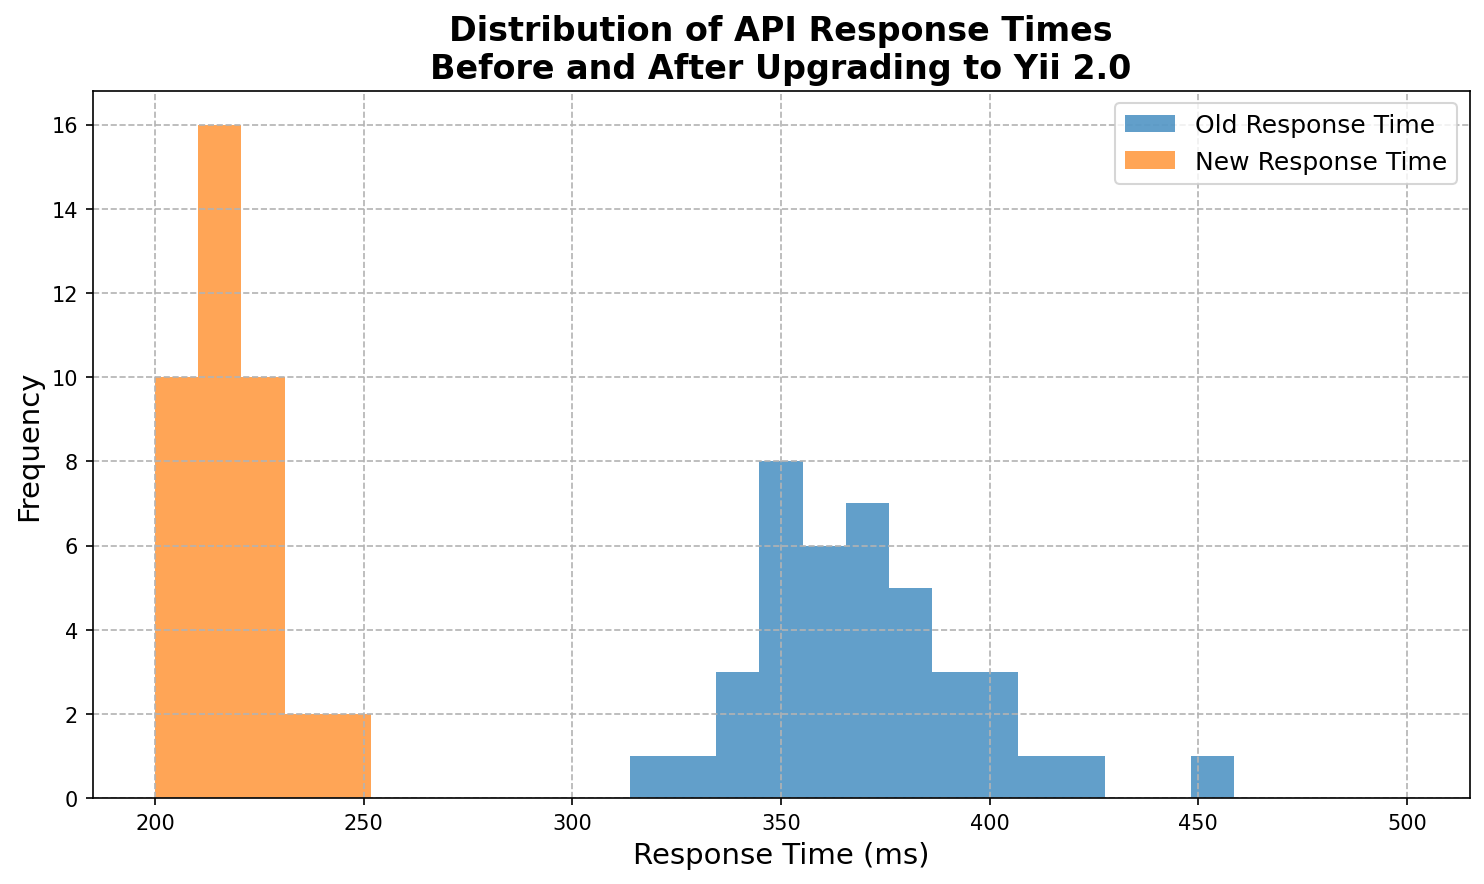What is the difference in the highest frequency bin between old and new response times? To find the highest frequency bin for each dataset, we need to identify the tallest bars in each histogram. Compare the heights of the tallest bars; the difference will be the difference in frequencies.
Answer: Approximately 4 Which response time range has the most significant improvement? Compare the bins where new response times show higher counts than old response times. Identify the range with the maximum difference in bar heights where new response times exceed old ones.
Answer: 200-250 ms Looking at the histogram, which response times were more frequent after upgrading to Yii 2.0 compared to before? Examine the bins where the new response times have higher bars than the old response times. The response times corresponding to these bins are the ones that became more frequent.
Answer: 200-250 ms How does the spread of old response times compare to the spread of new response times? Observe the range over which the bars for old response times are spread and compare it with the range over which the bars for new response times are spread.
Answer: Old response times are more spread out By how much did the response time decrease on average after upgrading to Yii 2.0? Estimate the central tendency (mean) of both distributions by looking at the peak areas of the bins. Calculate the difference between the central peaks of the old and new histograms.
Answer: Approximately 125 ms What is the most frequent response time range for the old response times? Identify the tallest bar in the histogram for old response times and note the range it corresponds to.
Answer: 350-400 ms What visual cue indicates the effectiveness of upgrading to Yii 2.0 in terms of response times? Look for sections of the histogram where the new response times have significantly higher bars compared to old response times, indicating lower response times post-upgrade.
Answer: Taller bars in the lower response time ranges for new data Are there any response times that did not change significantly after the upgrade? Check for bins where the bars of old and new response times are of similar heights. These indicate response times that remained mostly unchanged.
Answer: 210-230 ms Which histogram (old or new) shows a more uniform distribution of response times? Compare the variations in the heights of bins across the histograms. A more uniform distribution will have less variation in bar heights.
Answer: New response times How does the lower tail of the distribution compare between old and new response times? Observe the bars in the lower response times region (near 200 ms). Compare the presence and height of the bars for both old and new response times in this region.
Answer: New response times have higher bars near the lower tail 